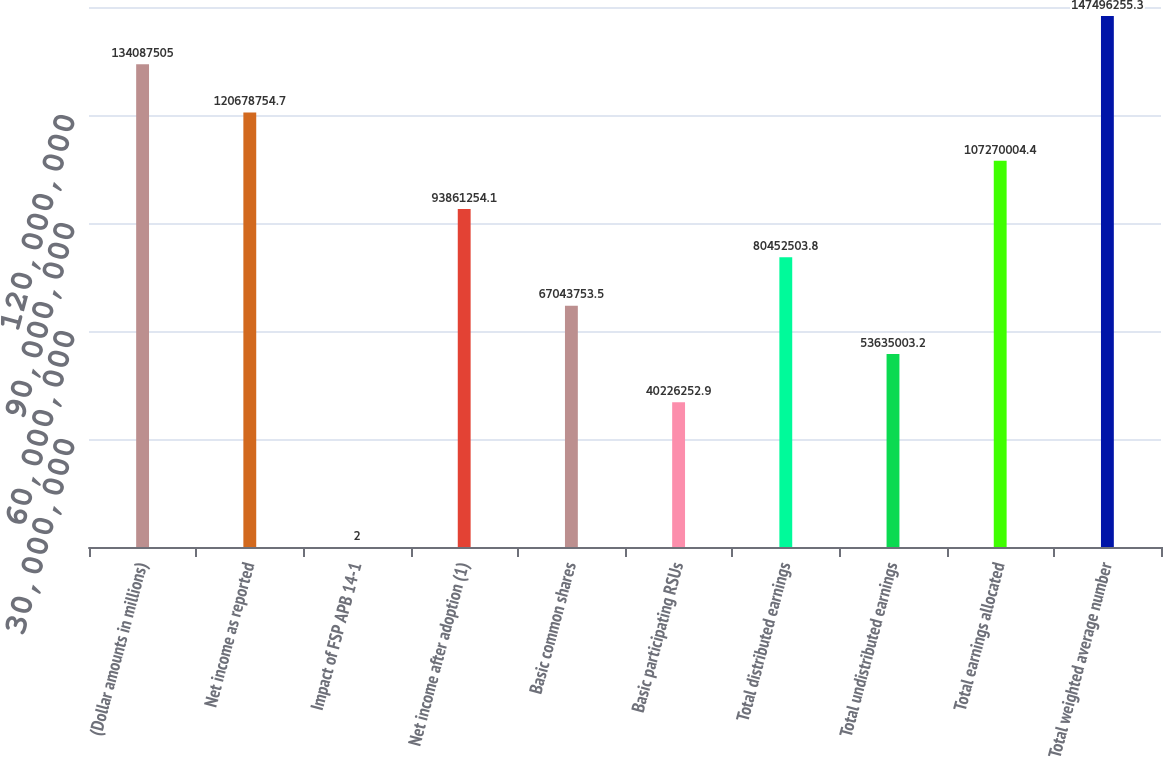<chart> <loc_0><loc_0><loc_500><loc_500><bar_chart><fcel>(Dollar amounts in millions)<fcel>Net income as reported<fcel>Impact of FSP APB 14-1<fcel>Net income after adoption (1)<fcel>Basic common shares<fcel>Basic participating RSUs<fcel>Total distributed earnings<fcel>Total undistributed earnings<fcel>Total earnings allocated<fcel>Total weighted average number<nl><fcel>1.34088e+08<fcel>1.20679e+08<fcel>2<fcel>9.38613e+07<fcel>6.70438e+07<fcel>4.02263e+07<fcel>8.04525e+07<fcel>5.3635e+07<fcel>1.0727e+08<fcel>1.47496e+08<nl></chart> 